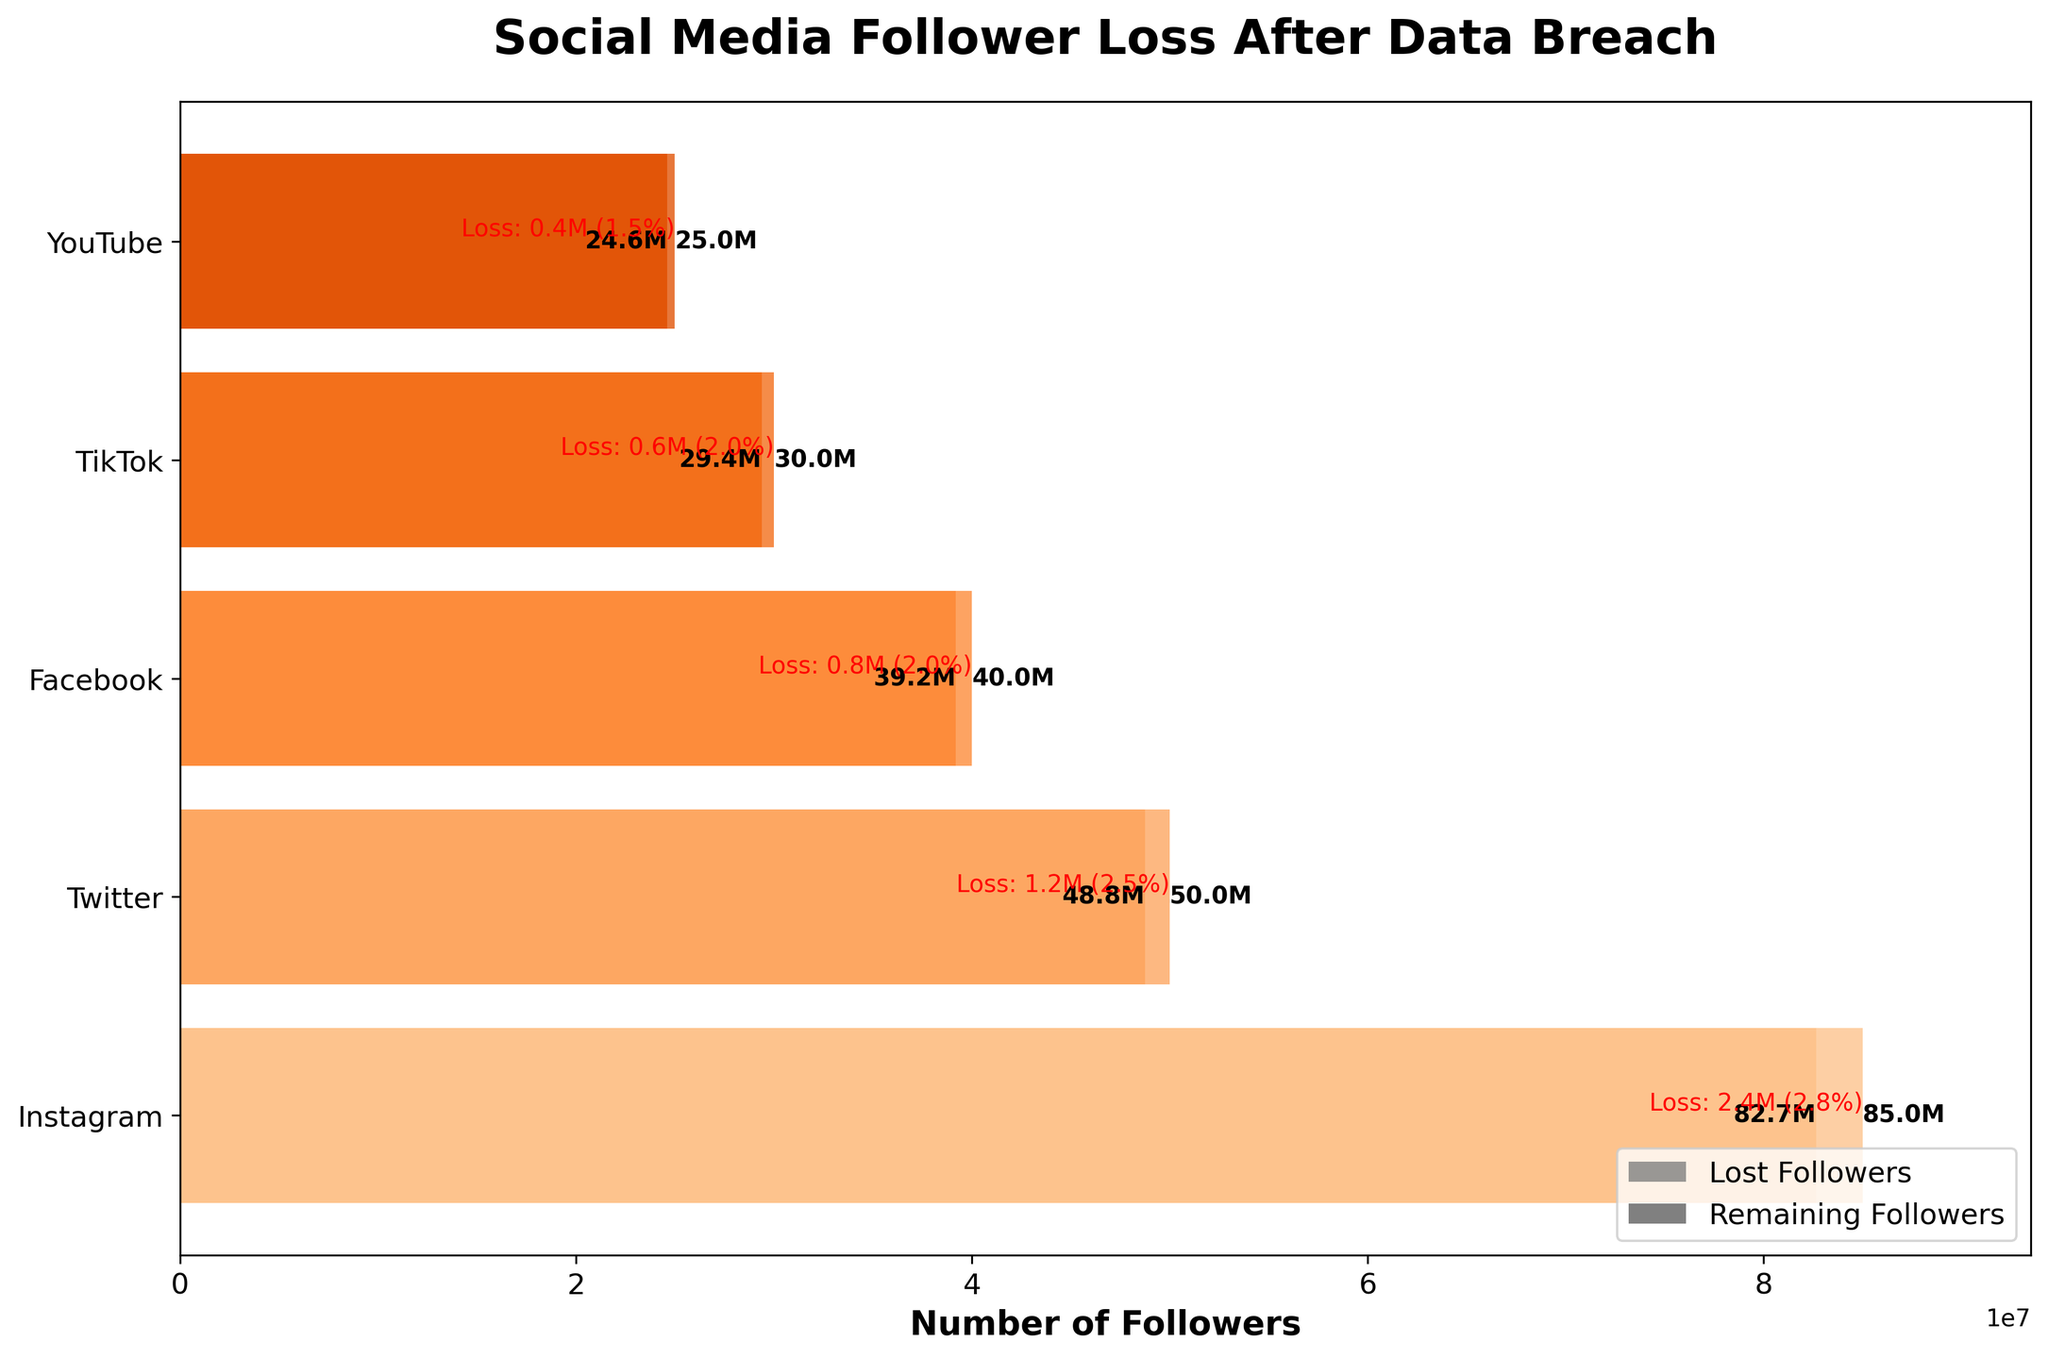what is the title of the figure? The title of the figure is usually placed at the top and it summarizes the main point of the plot. In this case, it is "Social Media Follower Loss After Data Breach"
Answer: Social Media Follower Loss After Data Breach how many platforms are represented in the figure? One can count the different bars in the funnel chart to determine the number of platforms. From the data, there are five platforms: Instagram, Twitter, Facebook, TikTok, and YouTube
Answer: 5 which platform had the highest initial number of followers? By looking at which bar starts with the largest value on the y-axis, you can determine that Instagram had the highest initial number of followers
Answer: Instagram which platform had the highest remaining number of followers? By looking at which bar remains the largest after the drop in followers, you can determine that Instagram still had the highest remaining number of followers
Answer: Instagram how many followers did YouTube lose after the data breach? The text on the YouTube bar indicating the loss can be directly referred to. It shows the drop in followers from 25 million to 24.625 million, i.e., 0.375 million
Answer: 0.375M what percentage of followers did Instagram lose after the data breach? The loss percentage is usually annotated on the bar. For Instagram: Loss = (85000000 - 82650000) / 85000000 * 100% = 2.8%
Answer: 2.8% compare the percentage of followers lost by Twitter and Facebook. Which one was greater? Calculate the percentage loss for each: Twitter: (50000000 - 48750000) / 50000000 * 100% = 2.5%; Facebook: (40000000 - 39200000) / 40000000 * 100% = 2.0%; Twitter lost a higher percentage of followers
Answer: Twitter what was the total number of initial followers across all platforms? Sum the initial followers for all platforms: 85000000 + 50000000 + 40000000 + 30000000 + 25000000 = 230000000
Answer: 230M what was the total number of followers remaining across all platforms after the data breach? Sum the remaining followers for all platforms: 82650000 + 48750000 + 39200000 + 29400000 + 24625000 = 224825000
Answer: 224.825M what is the total loss of followers across all platforms combined? Subtract the total remaining followers from the total initial followers: 230000000 - 224825000 = 5175000
Answer: 5175000 